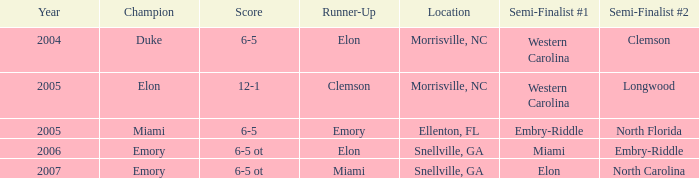When Embry-Riddle made it to the first semi finalist slot, list all the runners up. Emory. 